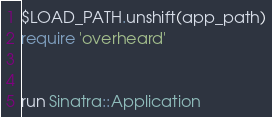<code> <loc_0><loc_0><loc_500><loc_500><_Ruby_>$LOAD_PATH.unshift(app_path)
require 'overheard'


run Sinatra::Application
</code> 